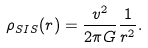<formula> <loc_0><loc_0><loc_500><loc_500>\rho _ { S I S } ( r ) = \frac { v ^ { 2 } } { 2 \pi G } \frac { 1 } { r ^ { 2 } } .</formula> 